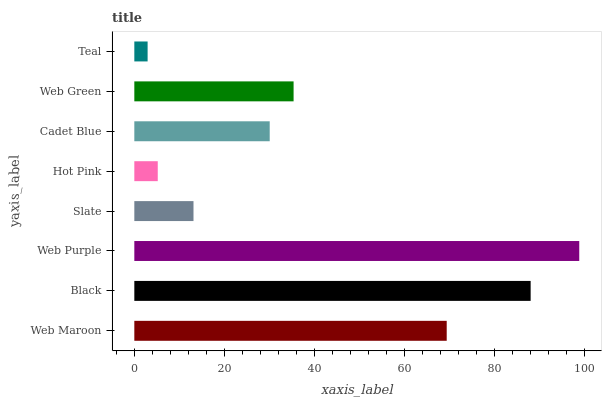Is Teal the minimum?
Answer yes or no. Yes. Is Web Purple the maximum?
Answer yes or no. Yes. Is Black the minimum?
Answer yes or no. No. Is Black the maximum?
Answer yes or no. No. Is Black greater than Web Maroon?
Answer yes or no. Yes. Is Web Maroon less than Black?
Answer yes or no. Yes. Is Web Maroon greater than Black?
Answer yes or no. No. Is Black less than Web Maroon?
Answer yes or no. No. Is Web Green the high median?
Answer yes or no. Yes. Is Cadet Blue the low median?
Answer yes or no. Yes. Is Web Maroon the high median?
Answer yes or no. No. Is Web Purple the low median?
Answer yes or no. No. 